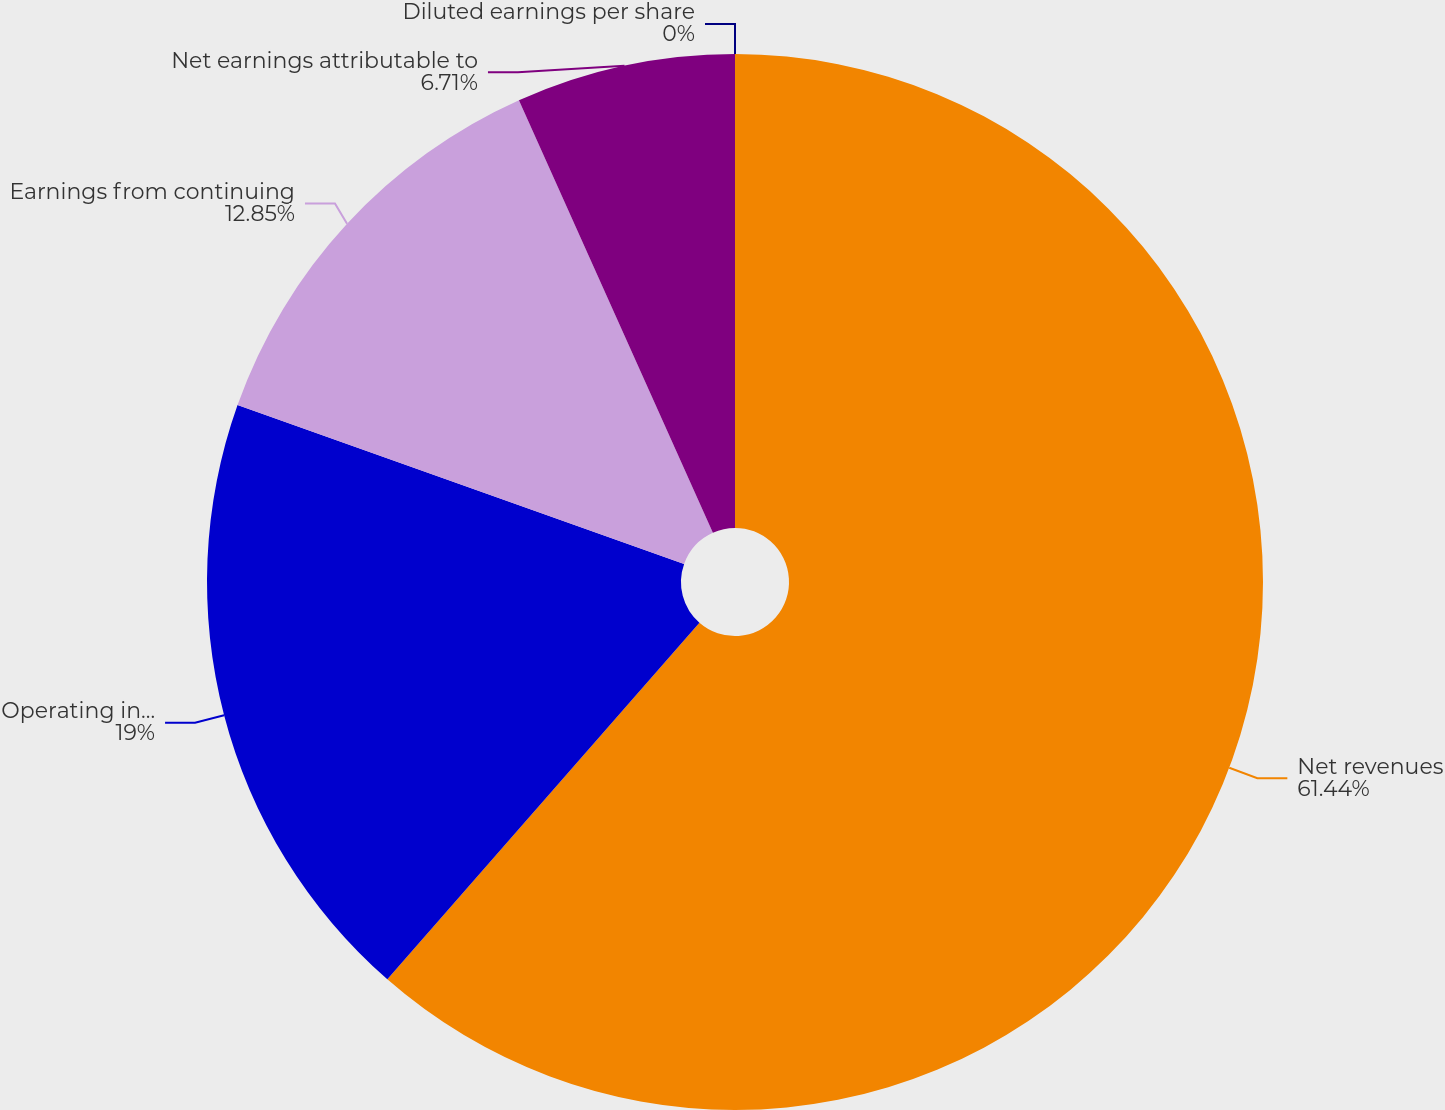Convert chart to OTSL. <chart><loc_0><loc_0><loc_500><loc_500><pie_chart><fcel>Net revenues<fcel>Operating income<fcel>Earnings from continuing<fcel>Net earnings attributable to<fcel>Diluted earnings per share<nl><fcel>61.44%<fcel>19.0%<fcel>12.85%<fcel>6.71%<fcel>0.0%<nl></chart> 